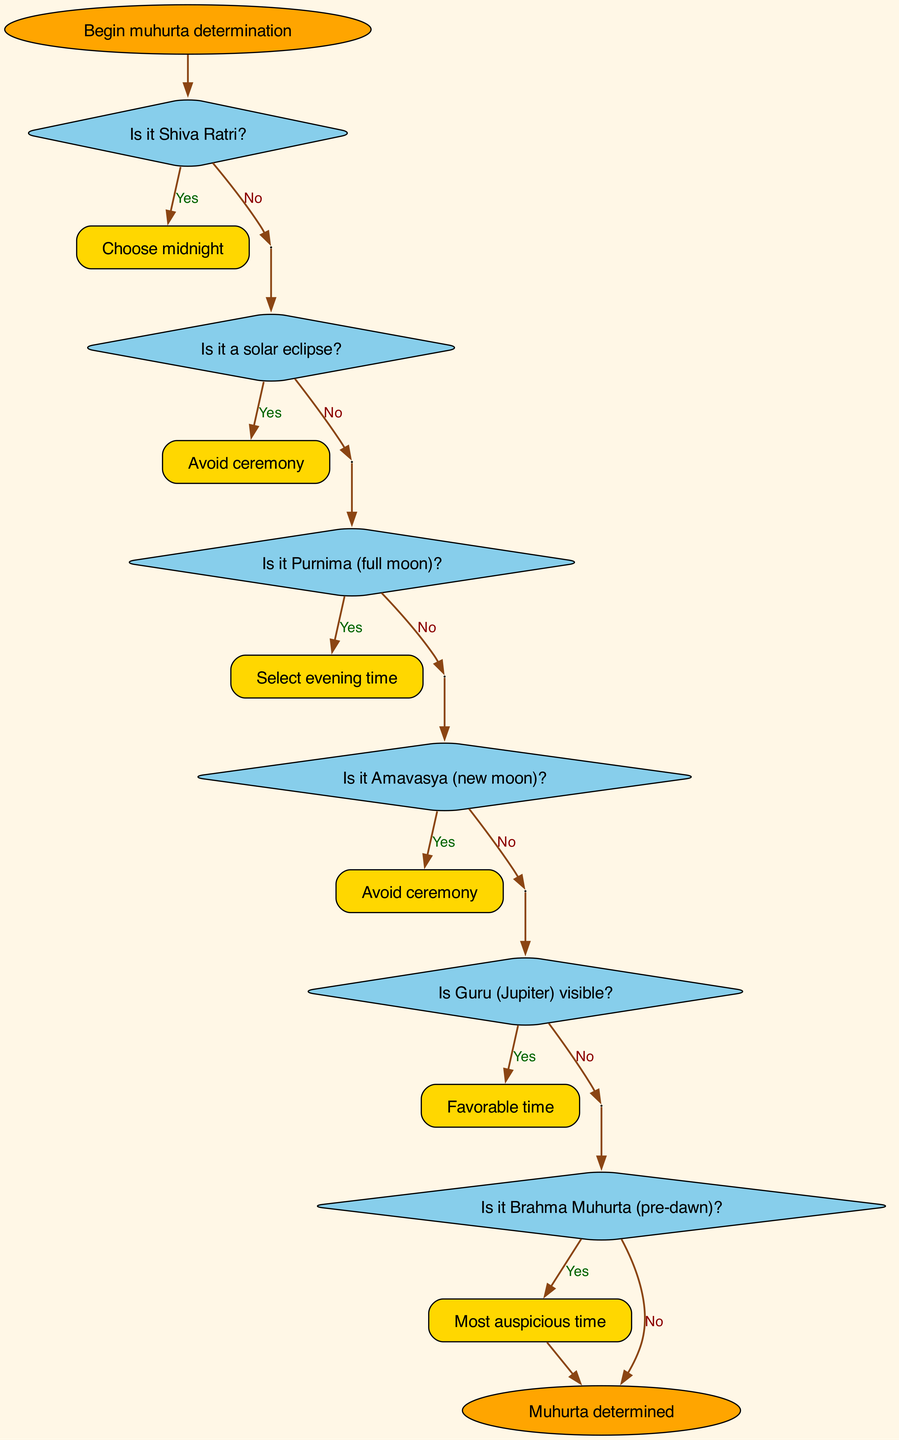What is the starting point of the flowchart? The flowchart begins with the node labeled "Begin muhurta determination." This is indicated as the first node in the diagram, signifying the start of the decision-making process.
Answer: Begin muhurta determination How many decision nodes are present in the flowchart? The flowchart features six decision nodes. Each decision is connected in sequence, indicating distinct conditions that affect the determination of auspicious times.
Answer: 6 What happens if it is Amavasya? If it is Amavasya (new moon), the flowchart indicates to "Avoid ceremony." This is specified as the outcome in the decision step regarding Amavasya.
Answer: Avoid ceremony Which node indicates the most auspicious time? The node corresponding to "Most auspicious time" appears after the decision regarding Brahma Muhurta, indicating this option is provided when Brahma Muhurta is confirmed to be present.
Answer: Most auspicious time What are the possible outcomes after determining if Guru is visible? After checking if Guru (Jupiter) is visible, if it is visible, the outcome is "Favorable time," and if not, the flowchart directs to the next decision—checking Brahma Muhurta. This results in two different paths based on the visibility of Guru.
Answer: Favorable time; Continue to next step What do you consult if Brahma Muhurta is not applicable? If Brahma Muhurta is not present, the flowchart suggests to "Consult Panchang for Shubha Muhurta," indicating that this is the appropriate action when Brahma Muhurta is not achievable.
Answer: Consult Panchang for Shubha Muhurta What decision leads directly to avoiding the ceremony? The decision regarding whether it is a solar eclipse leads directly to avoiding the ceremony if the answer is affirmative. This is a crucial point in the flowchart determining the feasibility of proceeding with the ceremony based on an eclipse.
Answer: Avoid ceremony What final outcome is achieved in the flowchart? The final outcome, represented by the end node, is "Muhurta determined," which signifies that the process has concluded with a suitable time for the religious ceremony being established as a result of the decisions made.
Answer: Muhurta determined 